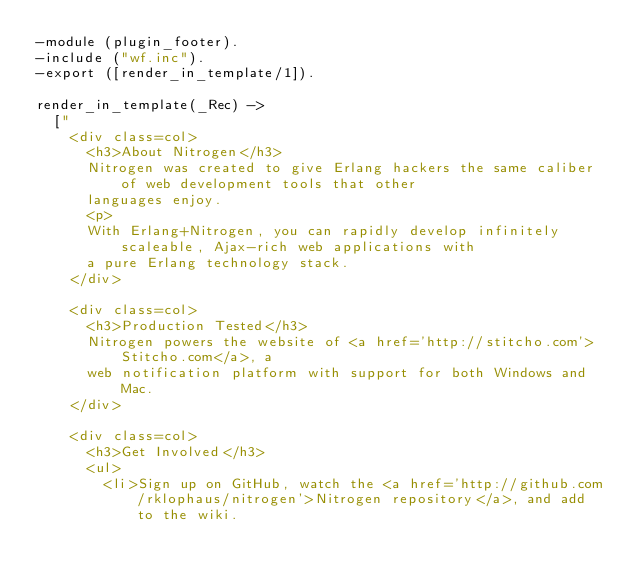Convert code to text. <code><loc_0><loc_0><loc_500><loc_500><_Erlang_>-module (plugin_footer).
-include ("wf.inc").
-export ([render_in_template/1]).

render_in_template(_Rec) ->
	["
		<div class=col>
			<h3>About Nitrogen</h3>
			Nitrogen was created to give Erlang hackers the same caliber of web development tools that other 
			languages enjoy.
			<p>
			With Erlang+Nitrogen, you can rapidly develop infinitely scaleable, Ajax-rich web applications with
			a pure Erlang technology stack.
		</div>

		<div class=col>
			<h3>Production Tested</h3>
			Nitrogen powers the website of <a href='http://stitcho.com'>Stitcho.com</a>, a 
			web notification platform with support for both Windows and Mac.
		</div>

		<div class=col>
			<h3>Get Involved</h3>
			<ul>
				<li>Sign up on GitHub, watch the <a href='http://github.com/rklophaus/nitrogen'>Nitrogen repository</a>, and add to the wiki.</code> 